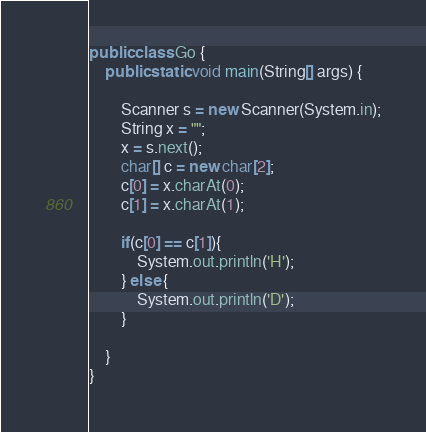<code> <loc_0><loc_0><loc_500><loc_500><_Java_>public class Go {
	public static void main(String[] args) {
		
		Scanner s = new Scanner(System.in);
		String x = "";
		x = s.next();
		char[] c = new char[2];
		c[0] = x.charAt(0);
		c[1] = x.charAt(1);
		
		if(c[0] == c[1]){
			System.out.println('H');
		} else {
			System.out.println('D');
		}
		
	}
}</code> 